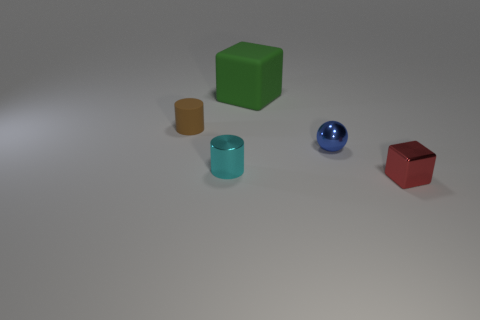Add 3 metal cylinders. How many objects exist? 8 Subtract all spheres. How many objects are left? 4 Add 3 blue spheres. How many blue spheres exist? 4 Subtract 0 green cylinders. How many objects are left? 5 Subtract all big red metallic blocks. Subtract all cyan cylinders. How many objects are left? 4 Add 2 cyan cylinders. How many cyan cylinders are left? 3 